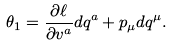<formula> <loc_0><loc_0><loc_500><loc_500>\theta _ { 1 } = \frac { \partial \ell } { \partial v ^ { a } } d q ^ { a } + p _ { \mu } d q ^ { \mu } .</formula> 